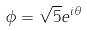Convert formula to latex. <formula><loc_0><loc_0><loc_500><loc_500>\phi = \sqrt { 5 } e ^ { i \theta }</formula> 